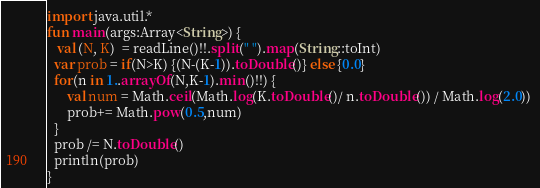<code> <loc_0><loc_0><loc_500><loc_500><_Kotlin_>import java.util.*
fun main(args:Array<String>) {
   val (N, K)  = readLine()!!.split(" ").map(String::toInt)
  var prob = if(N>K) {(N-(K-1)).toDouble()} else {0.0}
  for(n in 1..arrayOf(N,K-1).min()!!) {
      val num = Math.ceil(Math.log(K.toDouble()/ n.toDouble()) / Math.log(2.0)) 
      prob+= Math.pow(0.5,num)
  }
  prob /= N.toDouble()
  println(prob)
}</code> 